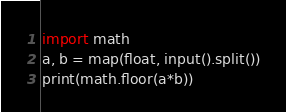<code> <loc_0><loc_0><loc_500><loc_500><_Python_>import math
a, b = map(float, input().split())
print(math.floor(a*b))</code> 